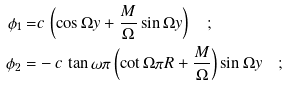Convert formula to latex. <formula><loc_0><loc_0><loc_500><loc_500>\phi _ { 1 } = & c \, \left ( \cos \Omega y + \frac { M } { \Omega } \sin \Omega y \right ) \quad ; \\ \phi _ { 2 } = & - c \, \tan \omega \pi \left ( \cot \Omega \pi R + \frac { M } { \Omega } \right ) \sin \Omega y \quad ;</formula> 